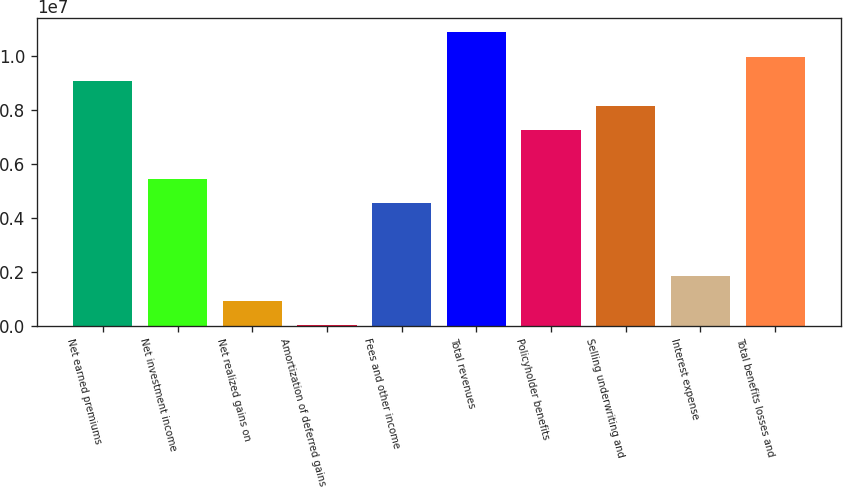Convert chart. <chart><loc_0><loc_0><loc_500><loc_500><bar_chart><fcel>Net earned premiums<fcel>Net investment income<fcel>Net realized gains on<fcel>Amortization of deferred gains<fcel>Fees and other income<fcel>Total revenues<fcel>Policyholder benefits<fcel>Selling underwriting and<fcel>Interest expense<fcel>Total benefits losses and<nl><fcel>9.04766e+06<fcel>5.43512e+06<fcel>919445<fcel>16310<fcel>4.53198e+06<fcel>1.08539e+07<fcel>7.24139e+06<fcel>8.14452e+06<fcel>1.82258e+06<fcel>9.95079e+06<nl></chart> 